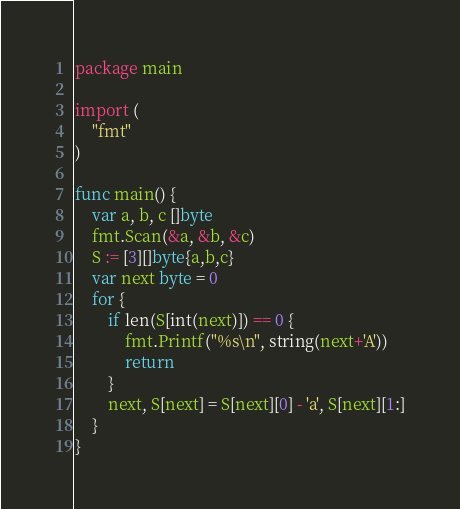Convert code to text. <code><loc_0><loc_0><loc_500><loc_500><_Go_>package main

import (
	"fmt"
)

func main() {
	var a, b, c []byte
	fmt.Scan(&a, &b, &c)
	S := [3][]byte{a,b,c}
	var next byte = 0
	for {
		if len(S[int(next)]) == 0 {
			fmt.Printf("%s\n", string(next+'A'))
			return
		}
		next, S[next] = S[next][0] - 'a', S[next][1:]
	}
}</code> 